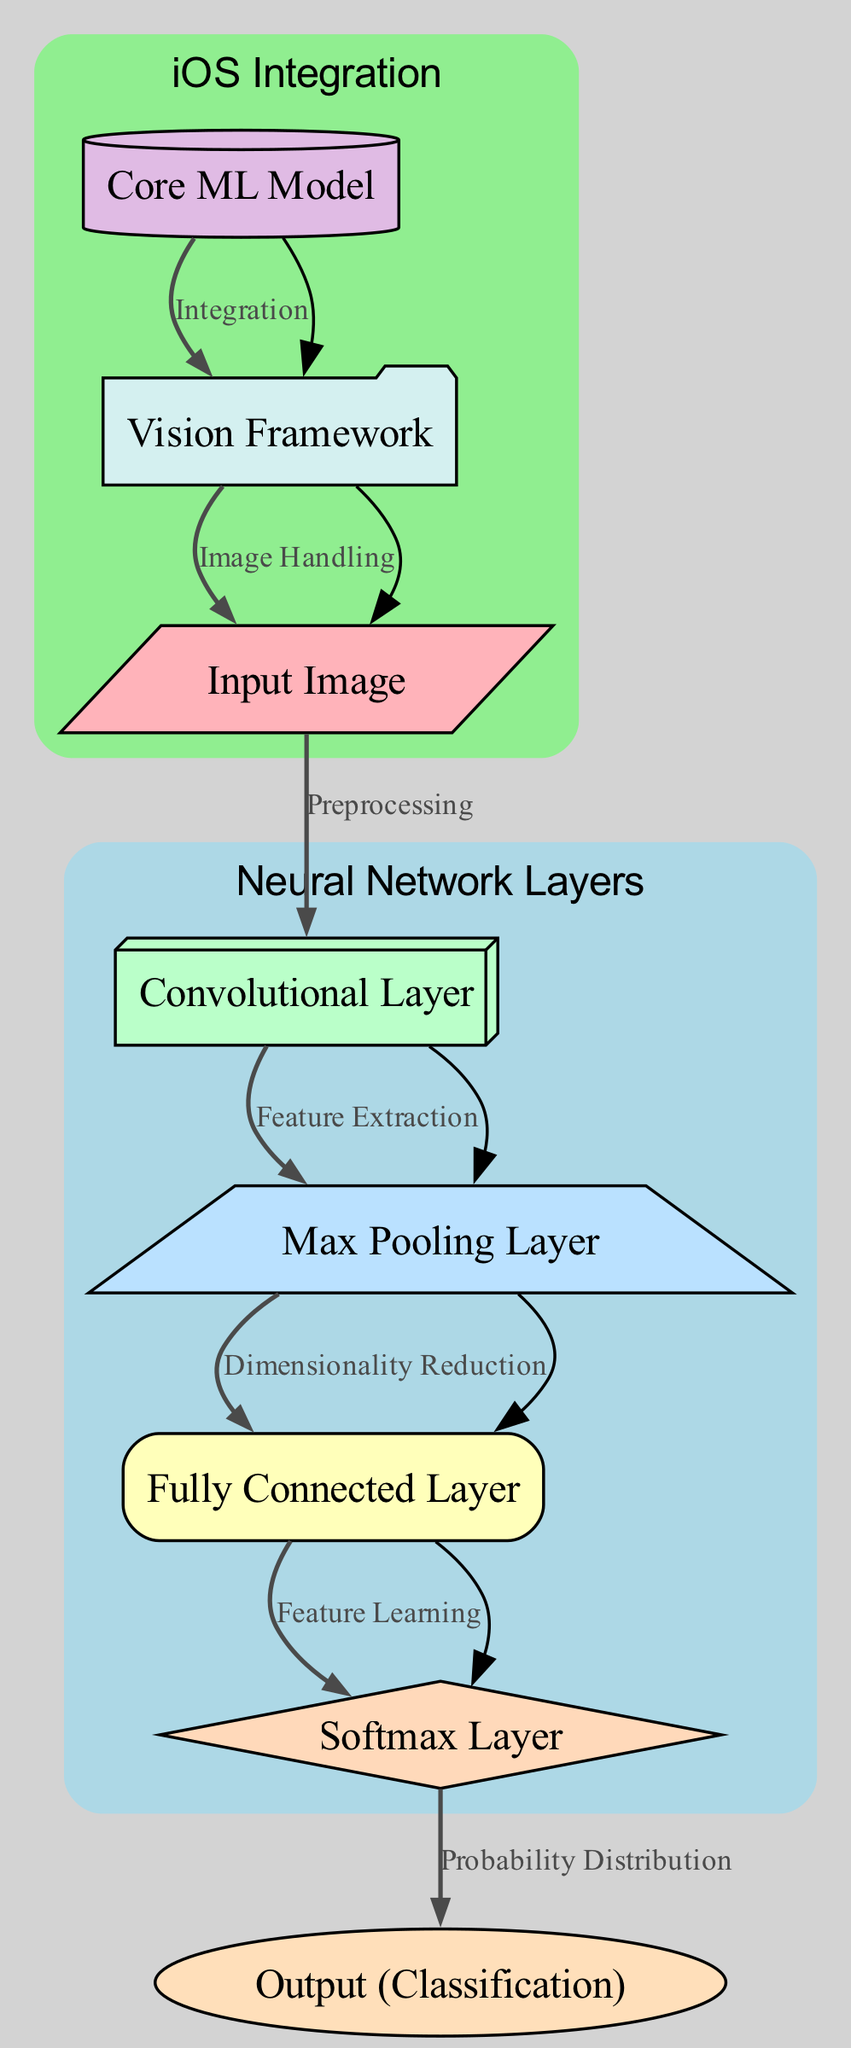What is the first node in the diagram? The first node is labeled "Input Image". According to the diagram's structure, the flow begins at this node, making it the starting point for image processing.
Answer: Input Image How many total nodes are in the diagram? The diagram contains 8 nodes, as evidenced by the node list, which includes "Input Image", "Convolutional Layer", "Max Pooling Layer", "Fully Connected Layer", "Softmax Layer", "Output (Classification)", "Core ML Model", and "Vision Framework".
Answer: 8 What is the label of the last node? The last node in the diagram is labeled "Output (Classification)", as shown in the sequence of nodes and their aforementioned classifications which flow in the direction of output.
Answer: Output Classification Which layer is responsible for dimensionality reduction? The layer responsible for dimensionality reduction is the "Max Pooling Layer", as indicated by the edge labeled "Dimensionality Reduction" connecting it from the "Convolutional Layer".
Answer: Max Pooling Layer What transformation occurs between the "Softmax Layer" and "Output (Classification)"? The transformation occurring is labeled "Probability Distribution", which indicates that the "Softmax Layer" outputs a probability distribution before moving on to the "Output (Classification)".
Answer: Probability Distribution What component handles image processing within iOS? The component that handles image processing within iOS is the "Vision Framework", which receives images from the Core ML Model and continues the chain of processing.
Answer: Vision Framework How do the "Core ML Model" and "Vision Framework" interact in the diagram? The "Core ML Model" and the "Vision Framework" interact through the edge labeled "Integration", indicating that they work together to incorporate machine learning capabilities into the application.
Answer: Integration Which node follows the "Convolutional Layer"? The node that follows the "Convolutional Layer" is the "Max Pooling Layer", as indicated by the directed edge showing the flow of data after feature extraction through to the pooling stage.
Answer: Max Pooling Layer What does the "Fully Connected Layer" perform? The "Fully Connected Layer" performs "Feature Learning", as noted on the diagram, suggesting that it processes the features extracted and pooled from previous layers to learn a representation of the input data.
Answer: Feature Learning 